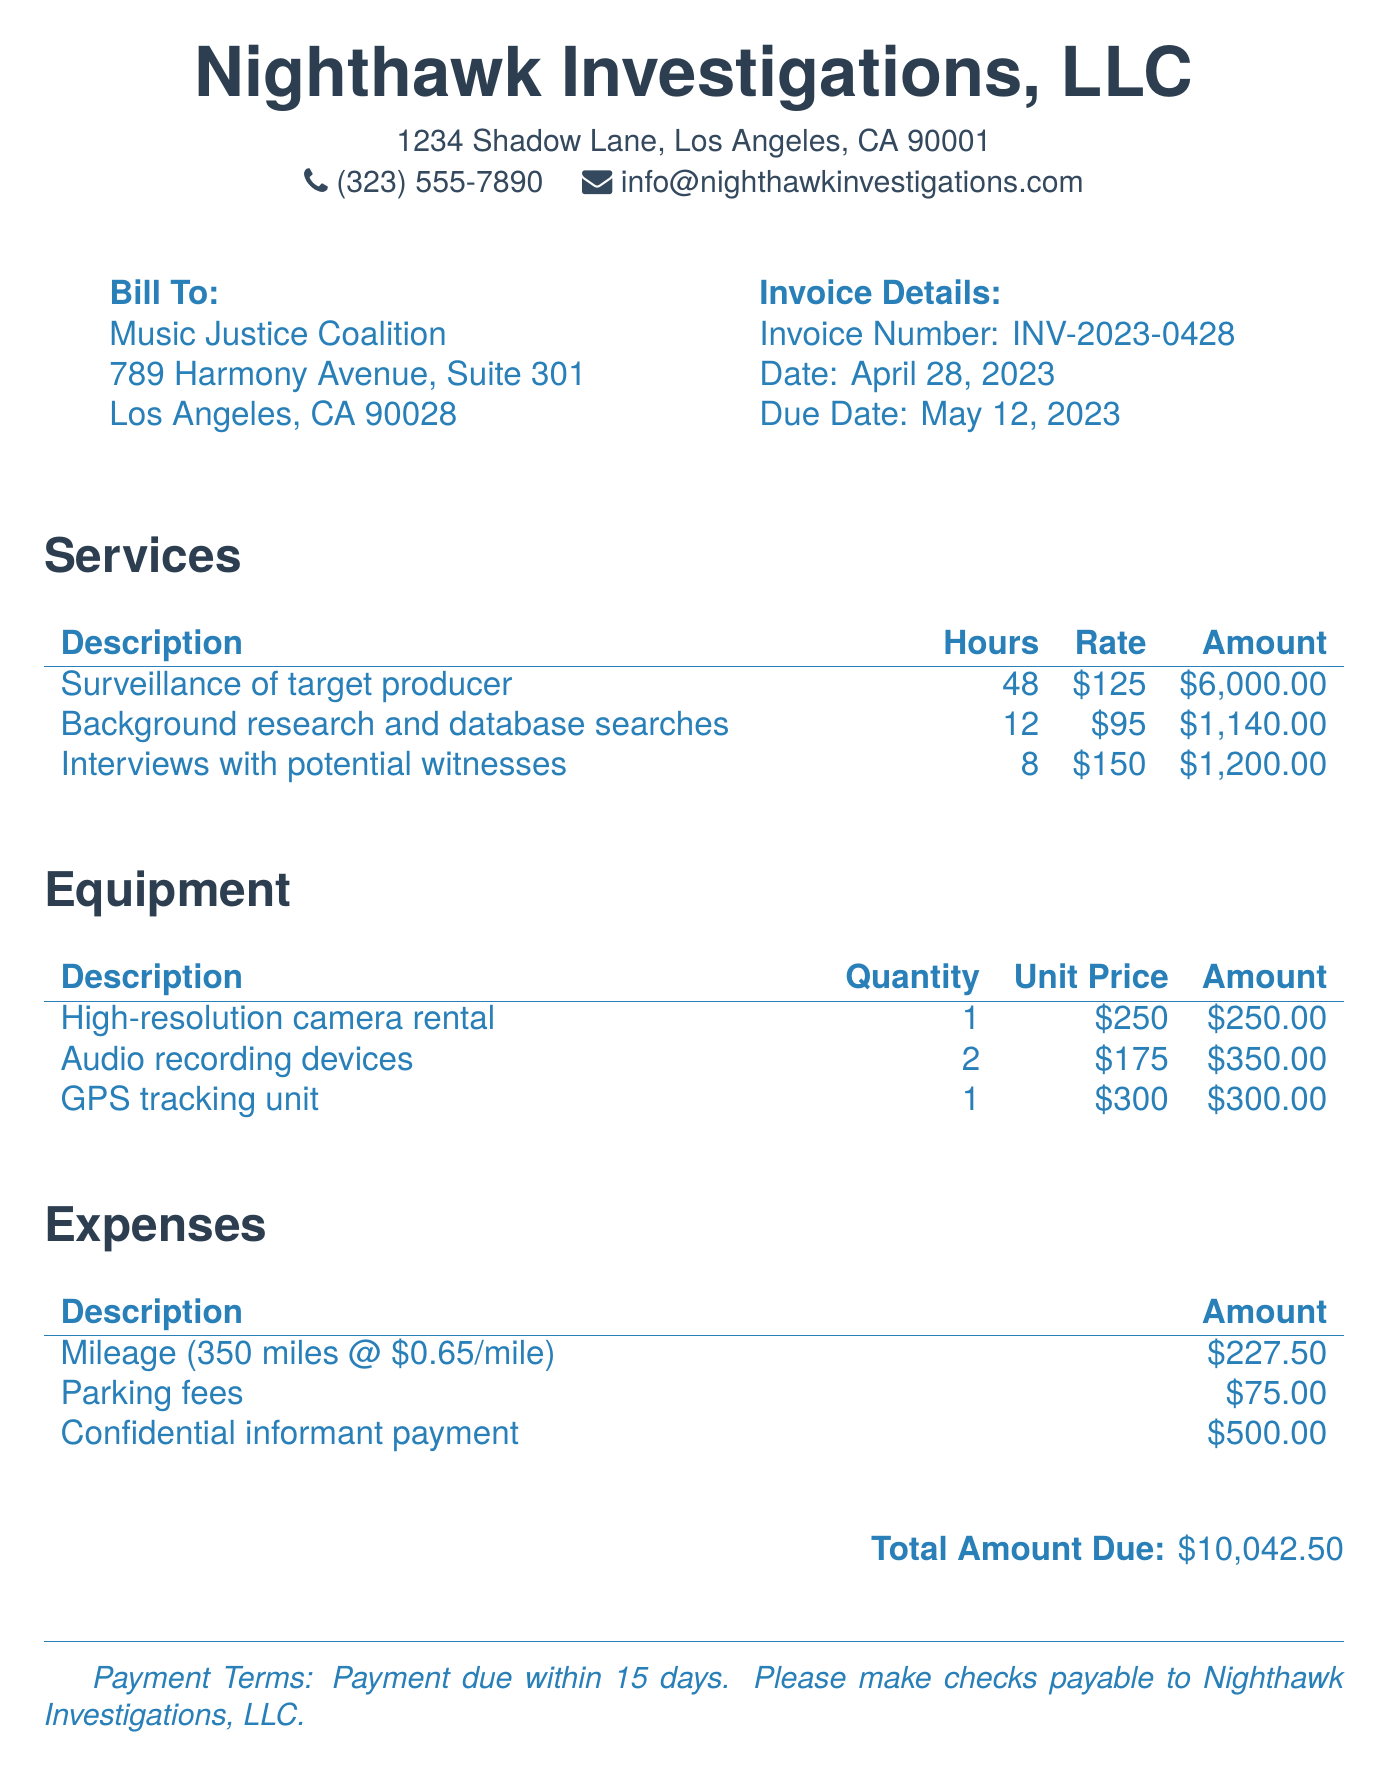what is the invoice number? The invoice number is explicitly stated in the document under Invoice Details.
Answer: INV-2023-0428 when is the due date for payment? The due date for payment is listed in the Invoice Details section.
Answer: May 12, 2023 how much is charged for surveillance of the target producer? The amount charged for surveillance is outlined in the Services section.
Answer: $6,000.00 what is the hourly rate for interviews with potential witnesses? The hourly rate for interviews is specified in the Services section.
Answer: $150 how many miles were billed for mileage expenses? The mileage billing is outlined in the Expenses section and calculated from the given rate.
Answer: 350 miles what is the total amount due on the invoice? The total amount due is provided at the end of the document.
Answer: $10,042.50 what type of business is this invoice from? The type of business is indicated in the header at the top of the document.
Answer: Nighthawk Investigations, LLC how many audio recording devices were rented? The quantity of audio recording devices is stated in the Equipment section.
Answer: 2 what payment method is suggested in the payment terms? The payment terms specify how payments should be made.
Answer: Checks payable to Nighthawk Investigations, LLC 